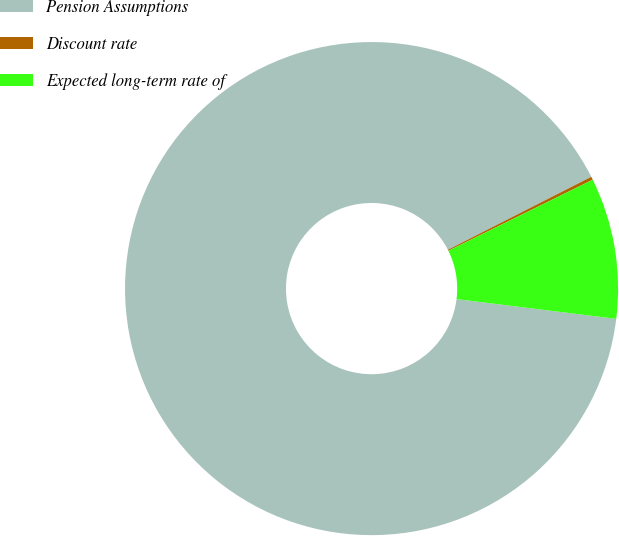Convert chart. <chart><loc_0><loc_0><loc_500><loc_500><pie_chart><fcel>Pension Assumptions<fcel>Discount rate<fcel>Expected long-term rate of<nl><fcel>90.55%<fcel>0.21%<fcel>9.24%<nl></chart> 